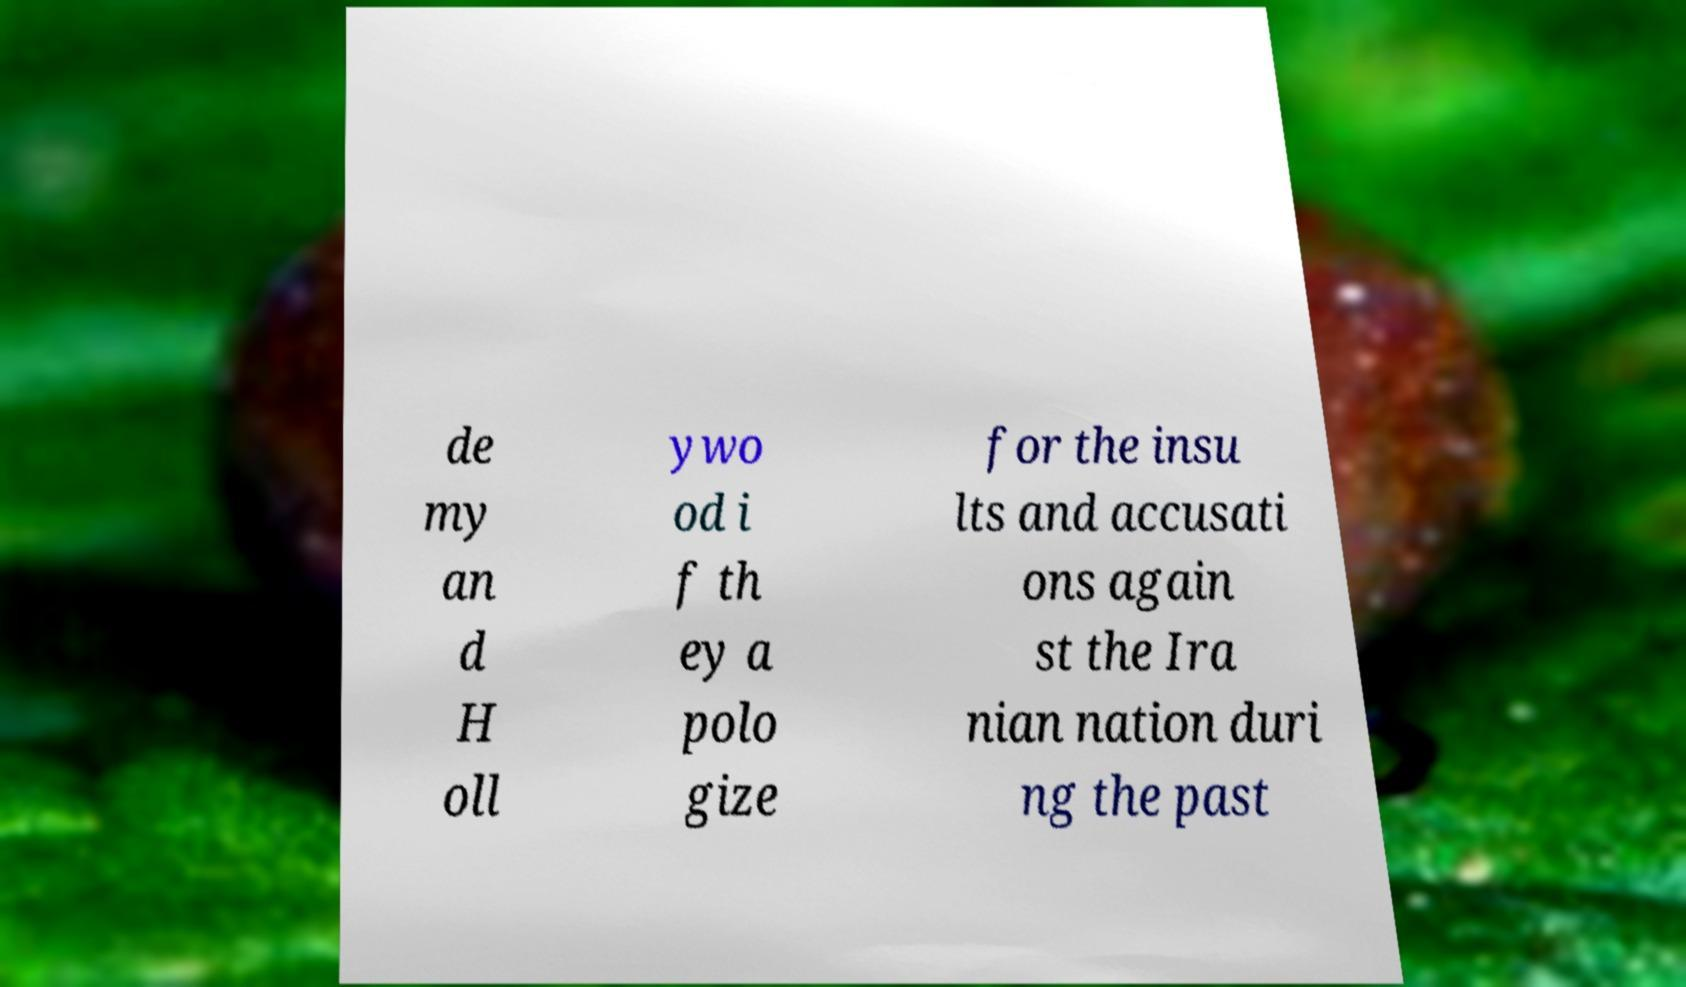Can you read and provide the text displayed in the image?This photo seems to have some interesting text. Can you extract and type it out for me? de my an d H oll ywo od i f th ey a polo gize for the insu lts and accusati ons again st the Ira nian nation duri ng the past 